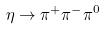Convert formula to latex. <formula><loc_0><loc_0><loc_500><loc_500>\eta \rightarrow \pi ^ { + } \pi ^ { - } \pi ^ { 0 }</formula> 